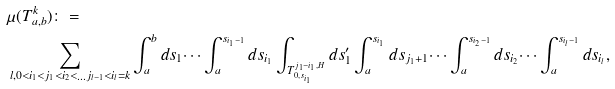<formula> <loc_0><loc_0><loc_500><loc_500>& \mu ( T _ { a , b } ^ { k } ) \colon = \\ & \sum _ { l , 0 < i _ { 1 } < j _ { 1 } < i _ { 2 } < \dots j _ { l - 1 } < i _ { l } = k } \int _ { a } ^ { b } d s _ { 1 } \dots \int _ { a } ^ { s _ { i _ { 1 } - 1 } } d s _ { i _ { 1 } } \int _ { T _ { 0 , s _ { i _ { 1 } } } ^ { j _ { 1 } - i _ { 1 } , H } } d s ^ { \prime } _ { 1 } \int _ { a } ^ { s _ { i _ { 1 } } } d s _ { j _ { 1 } + 1 } \dots \int _ { a } ^ { s _ { i _ { 2 } - 1 } } d s _ { i _ { 2 } } \dots \int _ { a } ^ { s _ { i _ { l } - 1 } } d s _ { i _ { l } } ,</formula> 